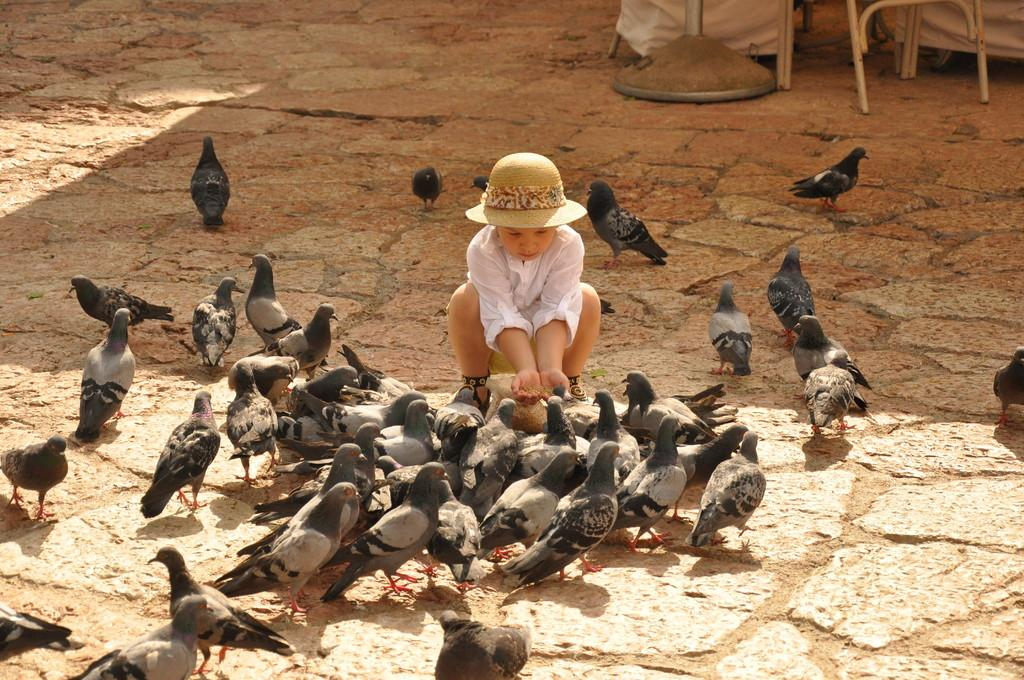What is the main subject of the image? The main subject of the image is a kid. What is the kid wearing in the image? The kid is wearing a white dress and a hat. Are there any animals visible in the image? Yes, there are pigeons on the land in front of the kid. What type of locket is the kid holding in the image? There is no locket visible in the image; the kid is not holding any object. Where is the library located in the image? There is no library present in the image; it is a scene featuring a kid and pigeons. 